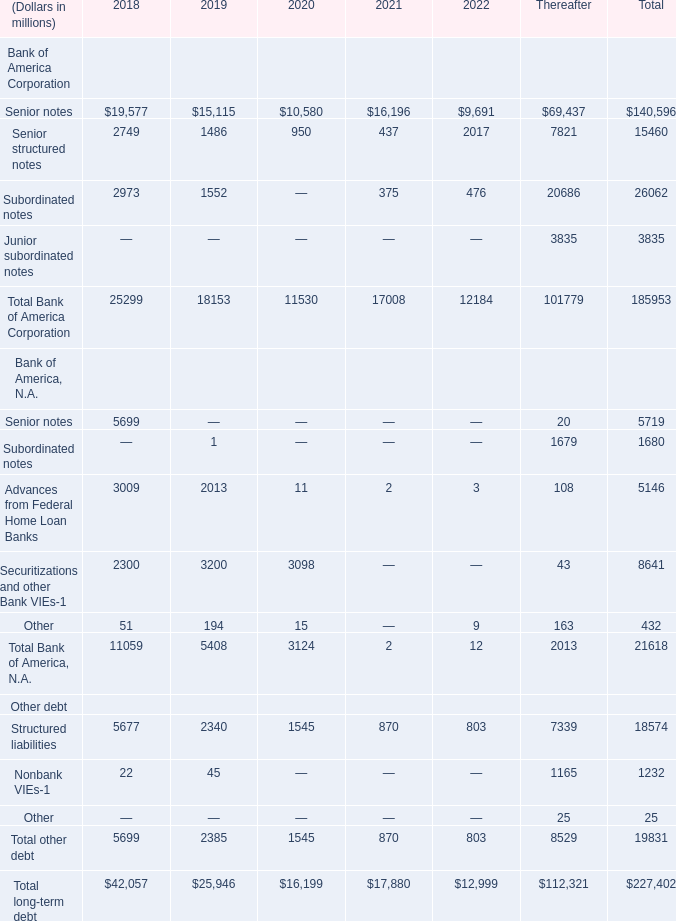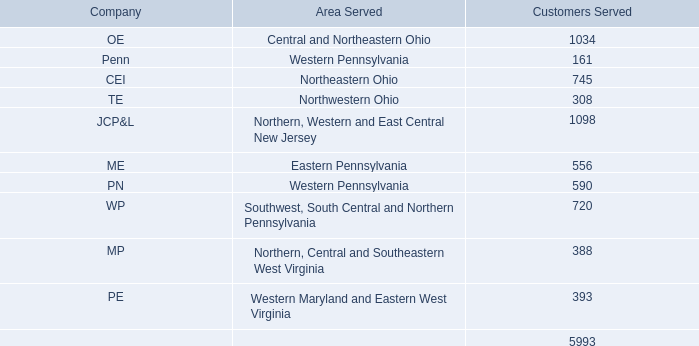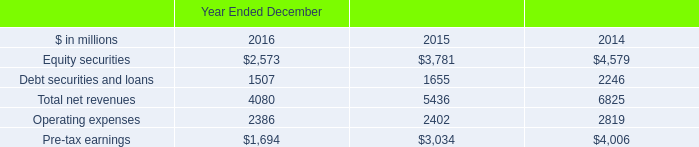What is the total amount of Operating expenses of Year Ended December 2016, Senior notes Bank of America, N.A. of 2018, and Advances from Federal Home Loan Banks Bank of America, N.A. of 2018 ? 
Computations: ((2386.0 + 5699.0) + 3009.0)
Answer: 11094.0. 